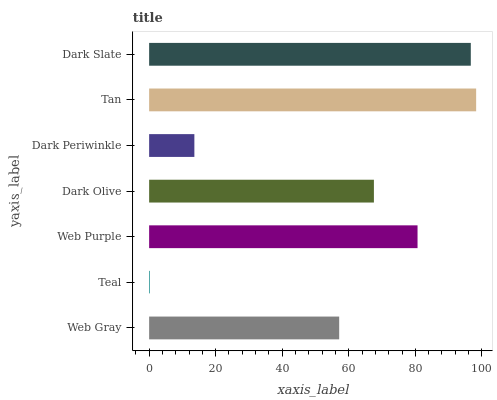Is Teal the minimum?
Answer yes or no. Yes. Is Tan the maximum?
Answer yes or no. Yes. Is Web Purple the minimum?
Answer yes or no. No. Is Web Purple the maximum?
Answer yes or no. No. Is Web Purple greater than Teal?
Answer yes or no. Yes. Is Teal less than Web Purple?
Answer yes or no. Yes. Is Teal greater than Web Purple?
Answer yes or no. No. Is Web Purple less than Teal?
Answer yes or no. No. Is Dark Olive the high median?
Answer yes or no. Yes. Is Dark Olive the low median?
Answer yes or no. Yes. Is Dark Periwinkle the high median?
Answer yes or no. No. Is Web Purple the low median?
Answer yes or no. No. 